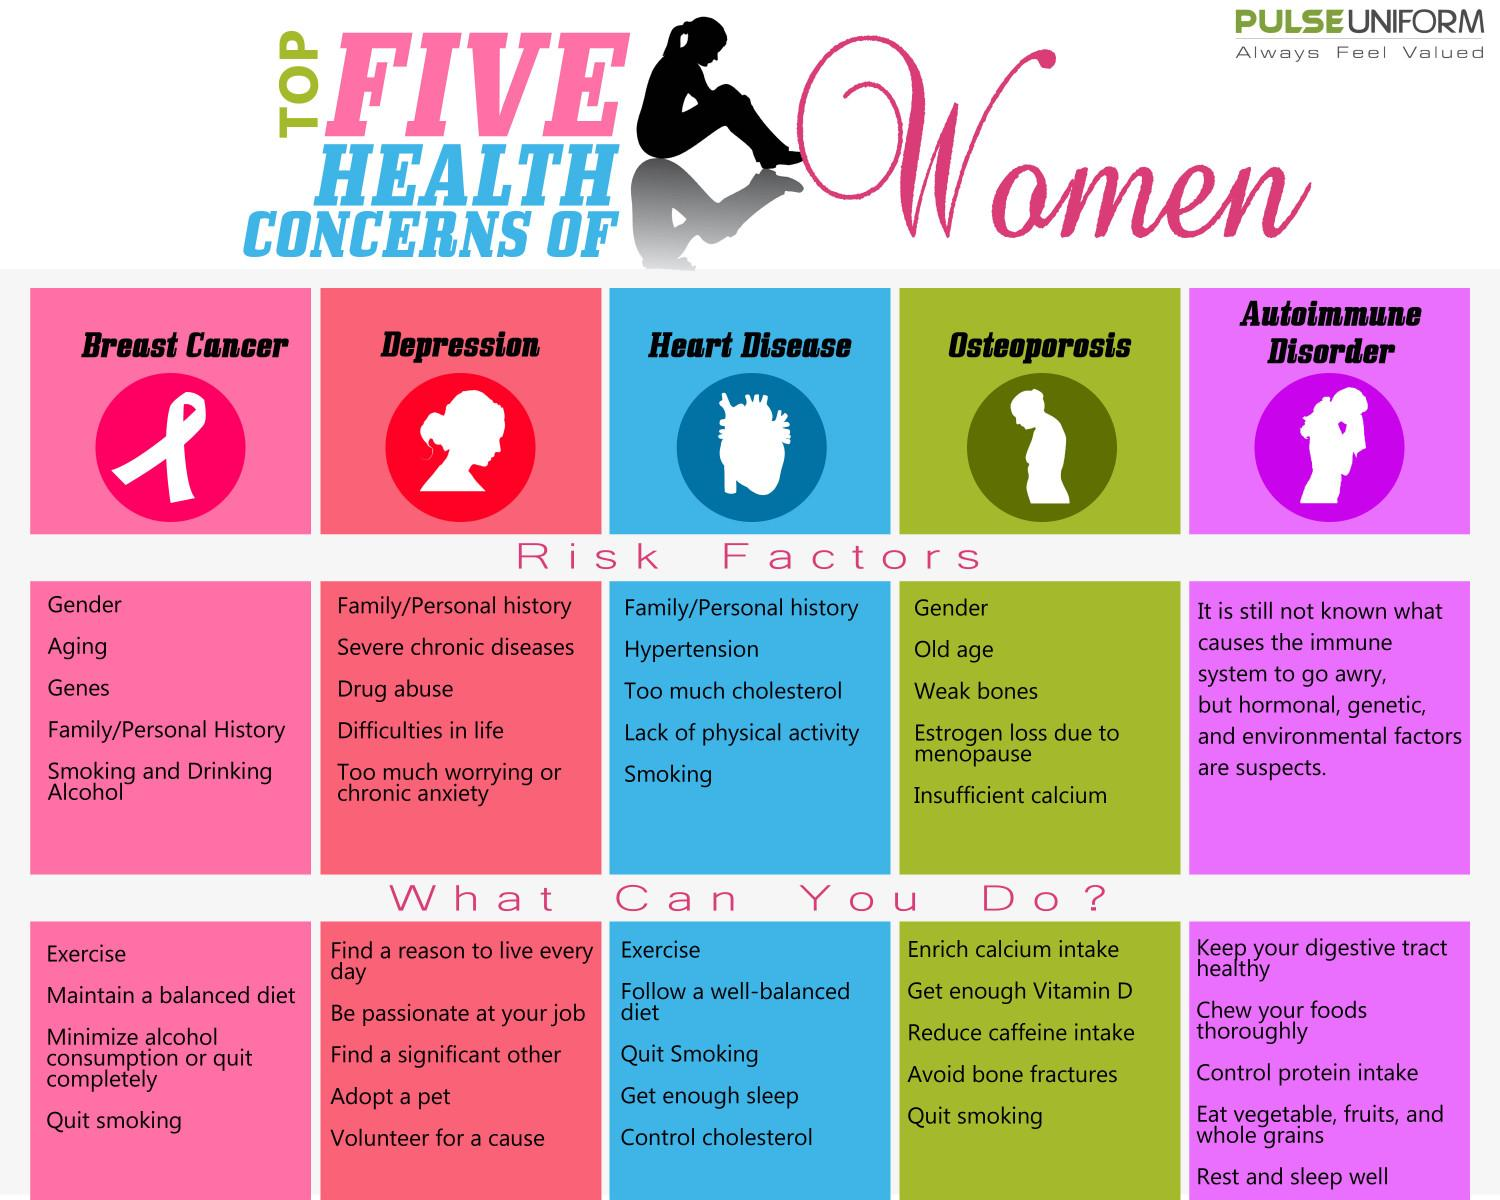Mention a couple of crucial points in this snapshot. Exercise has been shown to be effective in preventing and managing several diseases, including breast cancer and heart disease. Family history is a risk factor for several health concerns, including depression, heart disease, and breast cancer. Smoking should be quit in order to reduce the chances of developing breast cancer, heart disease, or osteoporosis. Gender is a common risk factor for both breast cancer and osteoporosis. 